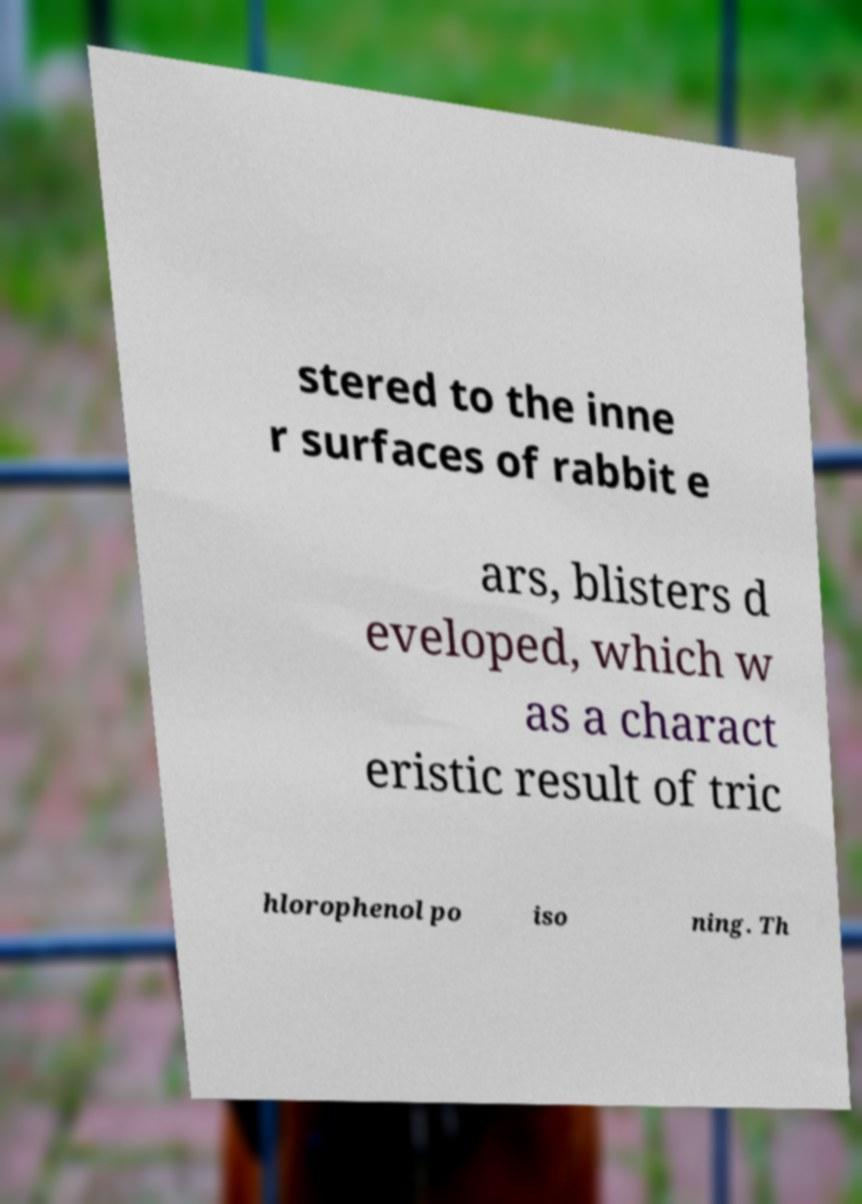Can you accurately transcribe the text from the provided image for me? stered to the inne r surfaces of rabbit e ars, blisters d eveloped, which w as a charact eristic result of tric hlorophenol po iso ning. Th 